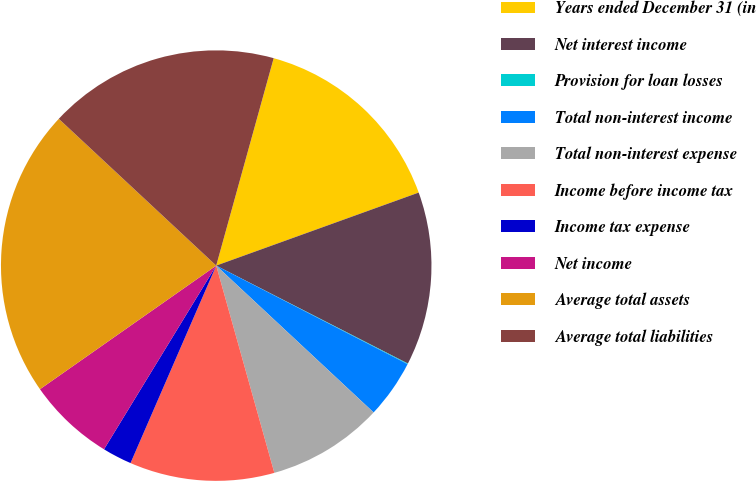Convert chart. <chart><loc_0><loc_0><loc_500><loc_500><pie_chart><fcel>Years ended December 31 (in<fcel>Net interest income<fcel>Provision for loan losses<fcel>Total non-interest income<fcel>Total non-interest expense<fcel>Income before income tax<fcel>Income tax expense<fcel>Net income<fcel>Average total assets<fcel>Average total liabilities<nl><fcel>15.19%<fcel>13.03%<fcel>0.05%<fcel>4.38%<fcel>8.7%<fcel>10.87%<fcel>2.21%<fcel>6.54%<fcel>21.68%<fcel>17.36%<nl></chart> 